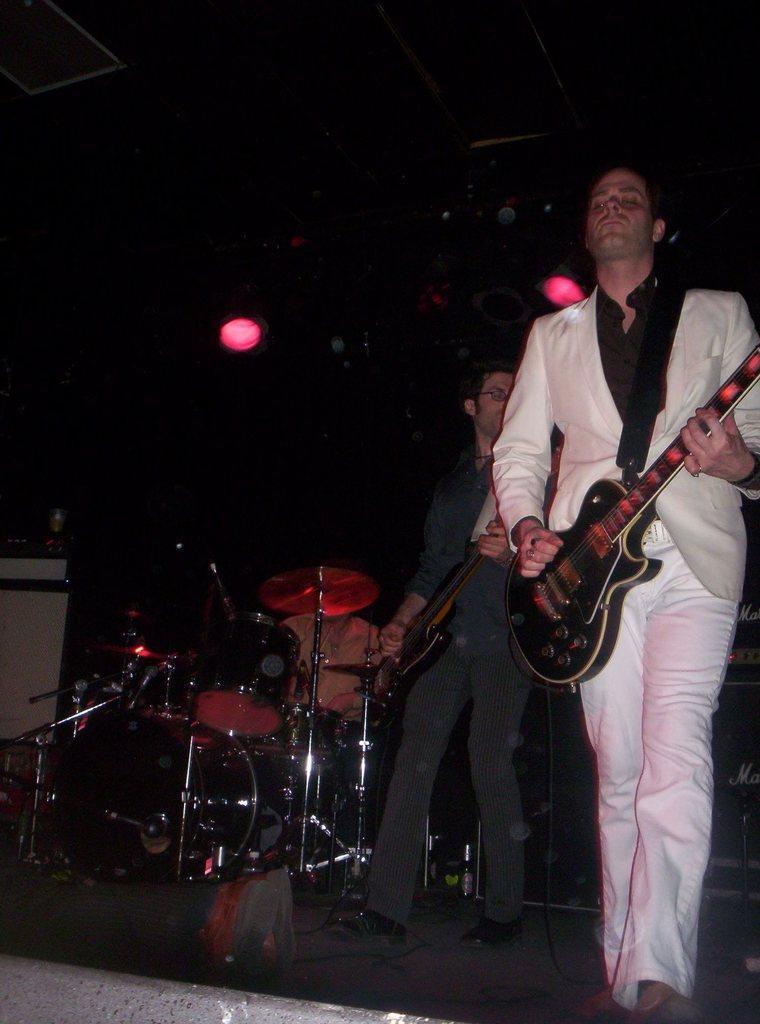Can you describe this image briefly? In this image I can see two men who are playing guitar on the stage. On the left side we have a musical instruments on the stage. 